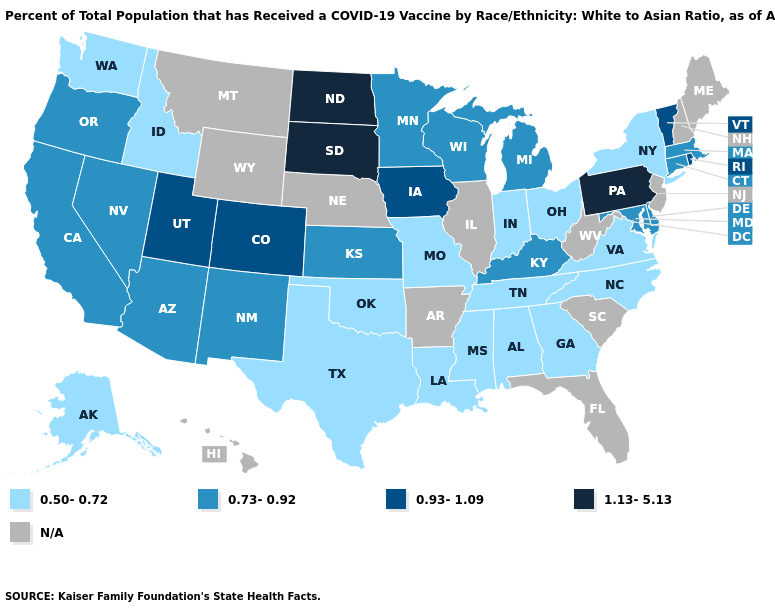Name the states that have a value in the range 0.50-0.72?
Answer briefly. Alabama, Alaska, Georgia, Idaho, Indiana, Louisiana, Mississippi, Missouri, New York, North Carolina, Ohio, Oklahoma, Tennessee, Texas, Virginia, Washington. What is the lowest value in the South?
Write a very short answer. 0.50-0.72. What is the highest value in states that border Tennessee?
Be succinct. 0.73-0.92. Which states have the highest value in the USA?
Keep it brief. North Dakota, Pennsylvania, South Dakota. Name the states that have a value in the range 0.73-0.92?
Write a very short answer. Arizona, California, Connecticut, Delaware, Kansas, Kentucky, Maryland, Massachusetts, Michigan, Minnesota, Nevada, New Mexico, Oregon, Wisconsin. Which states have the lowest value in the USA?
Be succinct. Alabama, Alaska, Georgia, Idaho, Indiana, Louisiana, Mississippi, Missouri, New York, North Carolina, Ohio, Oklahoma, Tennessee, Texas, Virginia, Washington. Does Nevada have the highest value in the West?
Concise answer only. No. What is the value of Kentucky?
Short answer required. 0.73-0.92. Name the states that have a value in the range N/A?
Keep it brief. Arkansas, Florida, Hawaii, Illinois, Maine, Montana, Nebraska, New Hampshire, New Jersey, South Carolina, West Virginia, Wyoming. Does Maryland have the lowest value in the USA?
Short answer required. No. What is the lowest value in the USA?
Give a very brief answer. 0.50-0.72. What is the highest value in the USA?
Keep it brief. 1.13-5.13. Name the states that have a value in the range 0.73-0.92?
Be succinct. Arizona, California, Connecticut, Delaware, Kansas, Kentucky, Maryland, Massachusetts, Michigan, Minnesota, Nevada, New Mexico, Oregon, Wisconsin. 